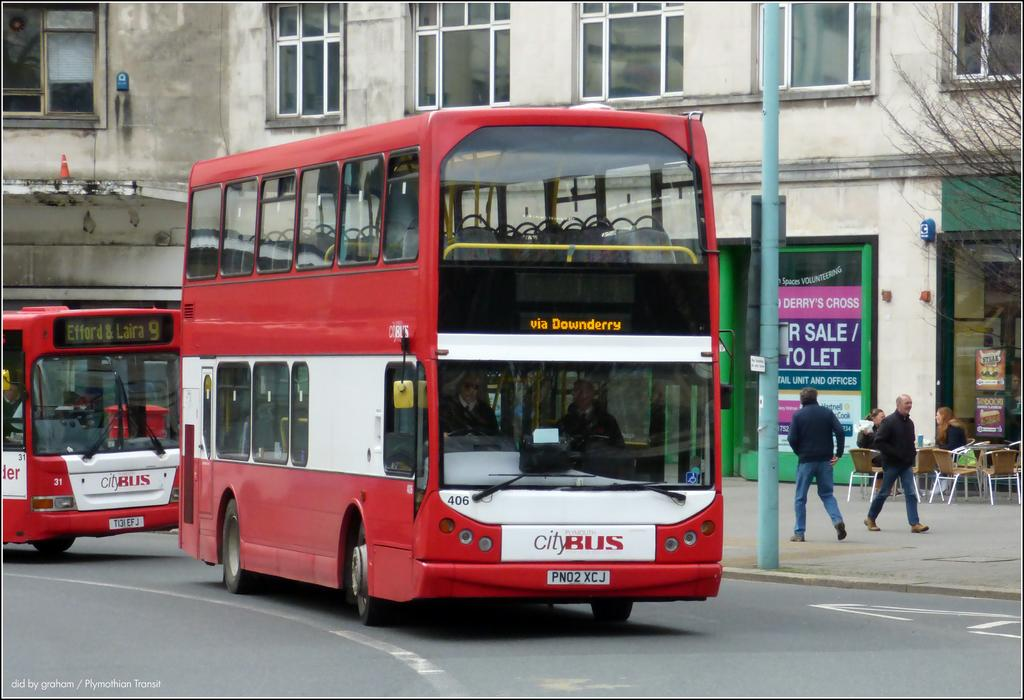<image>
Write a terse but informative summary of the picture. A Plymouth City bus is on the street. 